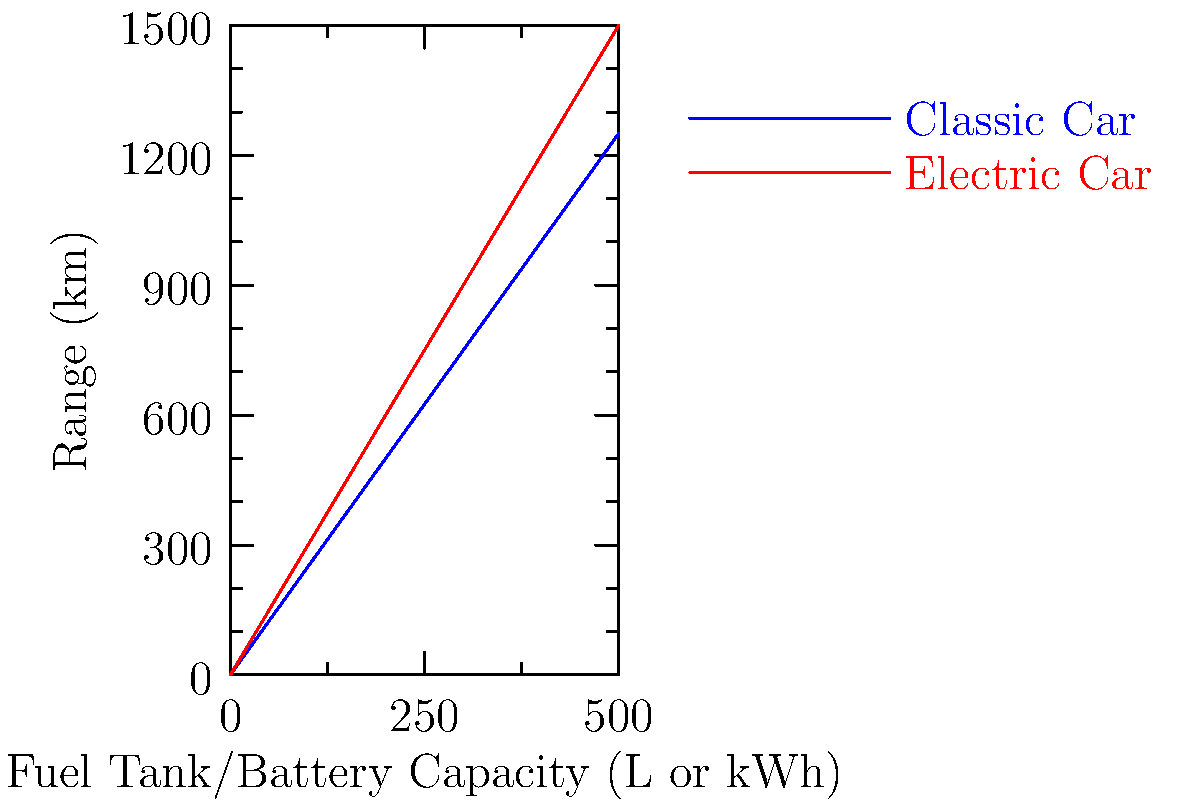Based on the line graph comparing the range of a classic car and an electric vehicle, at what fuel tank or battery capacity does the electric car's range surpass that of the classic car by 100 km? To solve this problem, we need to follow these steps:

1. Understand the graph:
   - Blue line represents the classic car's range
   - Red line represents the electric car's range
   - X-axis shows fuel tank/battery capacity
   - Y-axis shows range in km

2. Find the point where the difference between the two lines is 100 km:
   - At 0 capacity, both start at 0 km range
   - As capacity increases, both lines increase linearly
   - The electric car line has a steeper slope, indicating it gains range faster

3. Calculate the rate of range increase for each vehicle:
   - Classic car: $\frac{1250 \text{ km}}{500 \text{ L}} = 2.5 \text{ km/L}$
   - Electric car: $\frac{1500 \text{ km}}{500 \text{ kWh}} = 3 \text{ km/kWh}$

4. Set up an equation to find when the difference is 100 km:
   Let $x$ be the capacity in L or kWh
   $3x - 2.5x = 100$
   $0.5x = 100$

5. Solve the equation:
   $x = 100 \div 0.5 = 200$

Therefore, at 200 L or kWh of capacity, the electric car's range surpasses the classic car's range by 100 km.
Answer: 200 L or kWh 